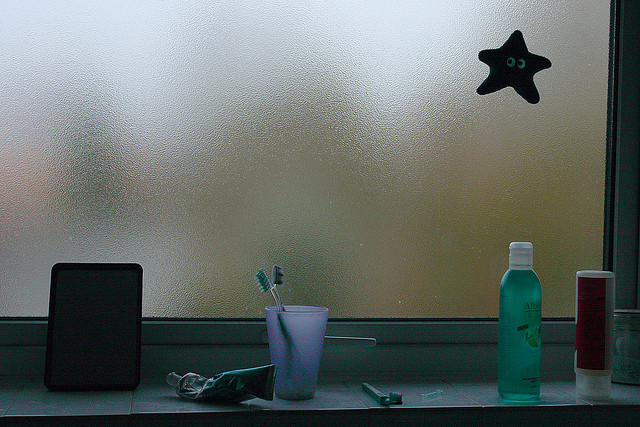<image>What brand are these toothbrushes? I am not sure what brand these toothbrushes are. It could be Colgate, Oral B, or Crest. What brand are these toothbrushes? I don't know what brand are these toothbrushes. It can be Colgate, Oral B, Crest or unknown. 